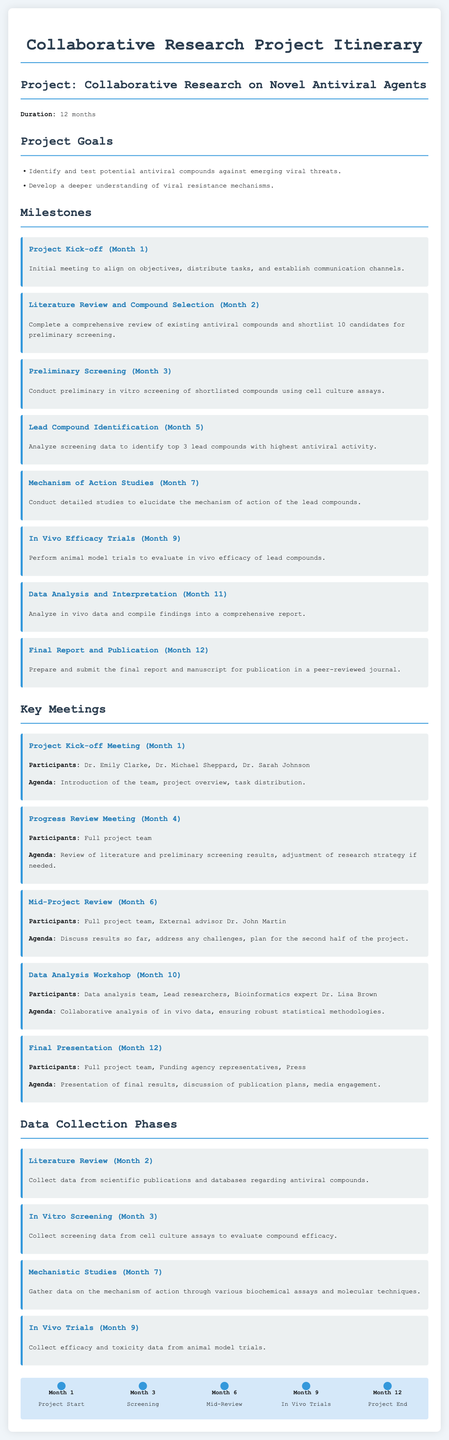What is the duration of the project? The project duration is explicitly stated as 12 months in the document.
Answer: 12 months Who are the participants in the Project Kick-off Meeting? The document lists Dr. Emily Clarke, Dr. Michael Sheppard, and Dr. Sarah Johnson as participants.
Answer: Dr. Emily Clarke, Dr. Michael Sheppard, Dr. Sarah Johnson When does the literature review occur? The specific month for the literature review phase is mentioned in the document.
Answer: Month 2 What is the goal related to viral resistance? The document refers to a specific goal concerning viral resistance mechanisms.
Answer: Develop a deeper understanding of viral resistance mechanisms How many lead compounds are identified in month 5? The document states the number of lead compounds identified at this milestone.
Answer: 3 Which meeting is scheduled for month 10? The document highlights a workshop scheduled during this month, specifying the type of meeting.
Answer: Data Analysis Workshop What type of data is collected during In Vivo Trials? The document describes the data collected during the In Vivo Trials phase.
Answer: Efficacy and toxicity data What is the final output expected at the end of the project? The document mentions what is to be prepared and submitted at the project’s conclusion.
Answer: Final report and publication 